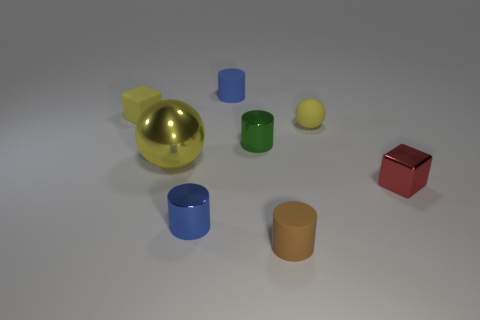Is there any other thing that is the same size as the yellow shiny ball?
Your response must be concise. No. The ball behind the ball on the left side of the yellow sphere right of the green shiny cylinder is what color?
Give a very brief answer. Yellow. There is a large yellow object; is it the same shape as the tiny yellow matte thing to the right of the brown cylinder?
Make the answer very short. Yes. There is a metallic object that is right of the small blue metal object and to the left of the small metal block; what is its color?
Ensure brevity in your answer.  Green. Is there another tiny matte thing that has the same shape as the tiny red thing?
Provide a succinct answer. Yes. Is the color of the metal sphere the same as the matte cube?
Offer a very short reply. Yes. There is a tiny yellow matte object to the left of the tiny yellow ball; are there any yellow matte objects to the right of it?
Your answer should be compact. Yes. What number of things are either yellow objects behind the large sphere or cylinders in front of the tiny yellow cube?
Ensure brevity in your answer.  5. What number of objects are either tiny yellow rubber things or blue things that are behind the brown rubber cylinder?
Keep it short and to the point. 4. What is the size of the yellow sphere on the left side of the matte object behind the small rubber object that is left of the big yellow shiny sphere?
Offer a very short reply. Large. 